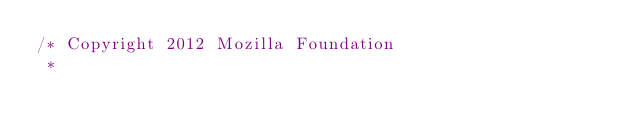<code> <loc_0><loc_0><loc_500><loc_500><_JavaScript_>/* Copyright 2012 Mozilla Foundation
 *</code> 